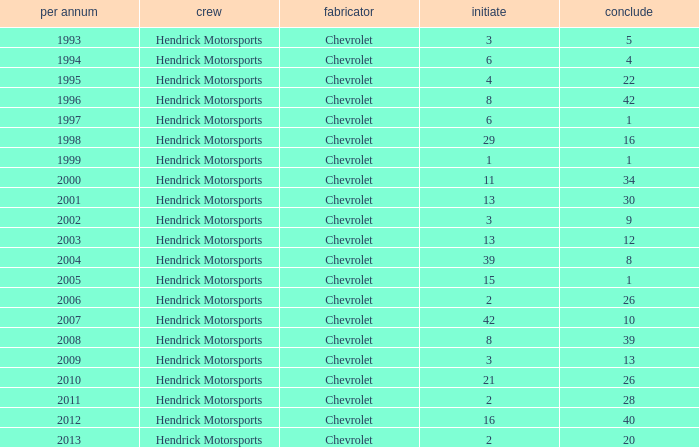Which team had a start of 8 in years under 2008? Hendrick Motorsports. 